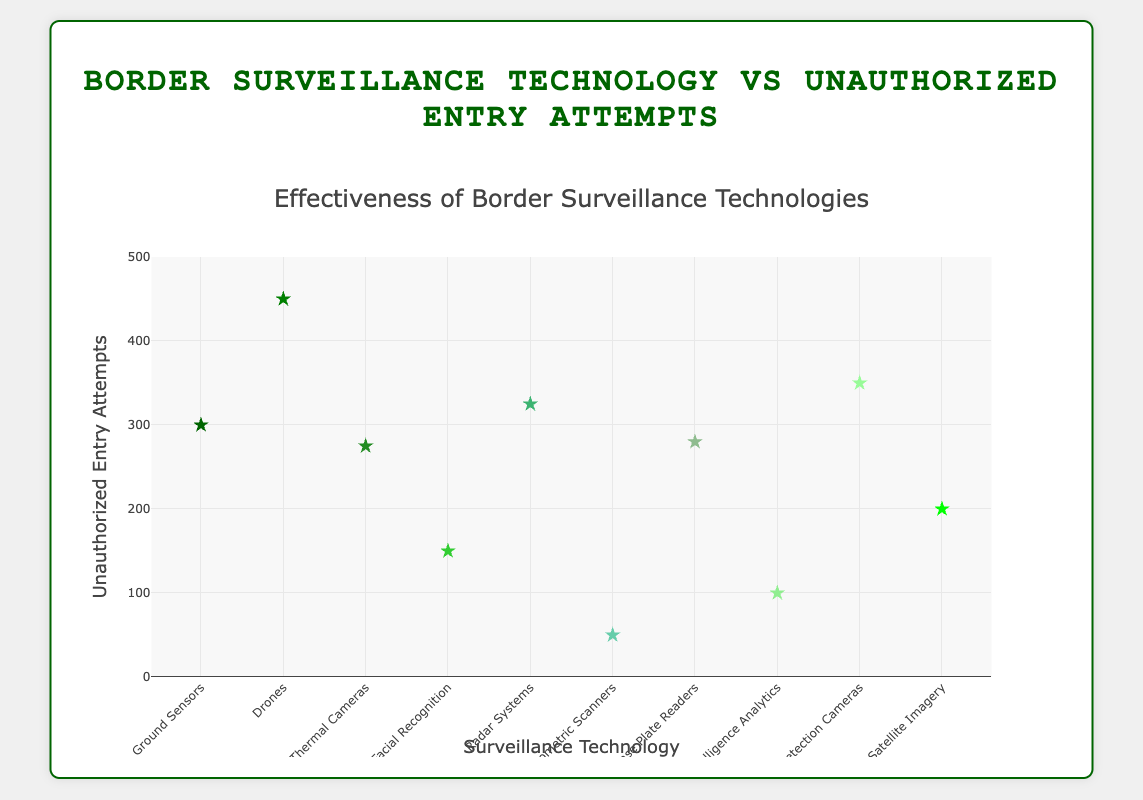What is the title of the plot? The title is displayed prominently at the top of the chart.
Answer: "Effectiveness of Border Surveillance Technologies" What are the x and y axes labeled as? The x-axis is labeled as "Surveillance Technology" and the y-axis as "Unauthorized Entry Attempts", which can be seen at the axis titles.
Answer: x-axis: "Surveillance Technology", y-axis: "Unauthorized Entry Attempts" How many different surveillance technologies are shown in the plot? Count the unique data points along the x-axis, each representing a different technology.
Answer: 10 Which surveillance technology has the highest unauthorized entry attempts? Look for the data point with the highest value on the y-axis and read its corresponding label on the x-axis.
Answer: Drones (450) What is the color pattern of the markers? Observe the scatter plot markers and note the colors used.
Answer: Shades of green Which surveillance technology has the lowest unauthorized entry attempts? Find the data point with the lowest value on the y-axis and check its corresponding x-axis label.
Answer: Biometric Scanners (50) What is the median value of unauthorized entry attempts across all technologies? Arrange the unauthorized entry attempts values in ascending order and find the middle value or the average of the two middle values if the number of points is even: (50, 100, 150, 200, 275, 280, 300, 325, 350, 450). Middle values are 275 and 280; their average is (275+280)/2.
Answer: 277.5 Is Facial Recognition more or less effective than Thermal Cameras based on the plot? Compare the unauthorized entry attempts for Facial Recognition (150) and Thermal Cameras (275). Less unauthorized attempts imply higher effectiveness.
Answer: More effective Which two technologies have the closest number of unauthorized entry attempts? Compare the counts of unauthorized entry attempts and identify the two technologies with the least difference.
Answer: Automatic License Plate Readers (280) and Thermal Cameras (275) Which technology is indicated by the star symbol marker with a size of 12 and colored in a shade of green? All markers match this description, so specify any one data point.
Answer: Ground Sensors, Drones, Thermal Cameras, Facial Recognition, Radar Systems, Biometric Scanners, Automatic License Plate Readers, Artificial Intelligence Analytics, Motion Detection Cameras, or Satellite Imagery 